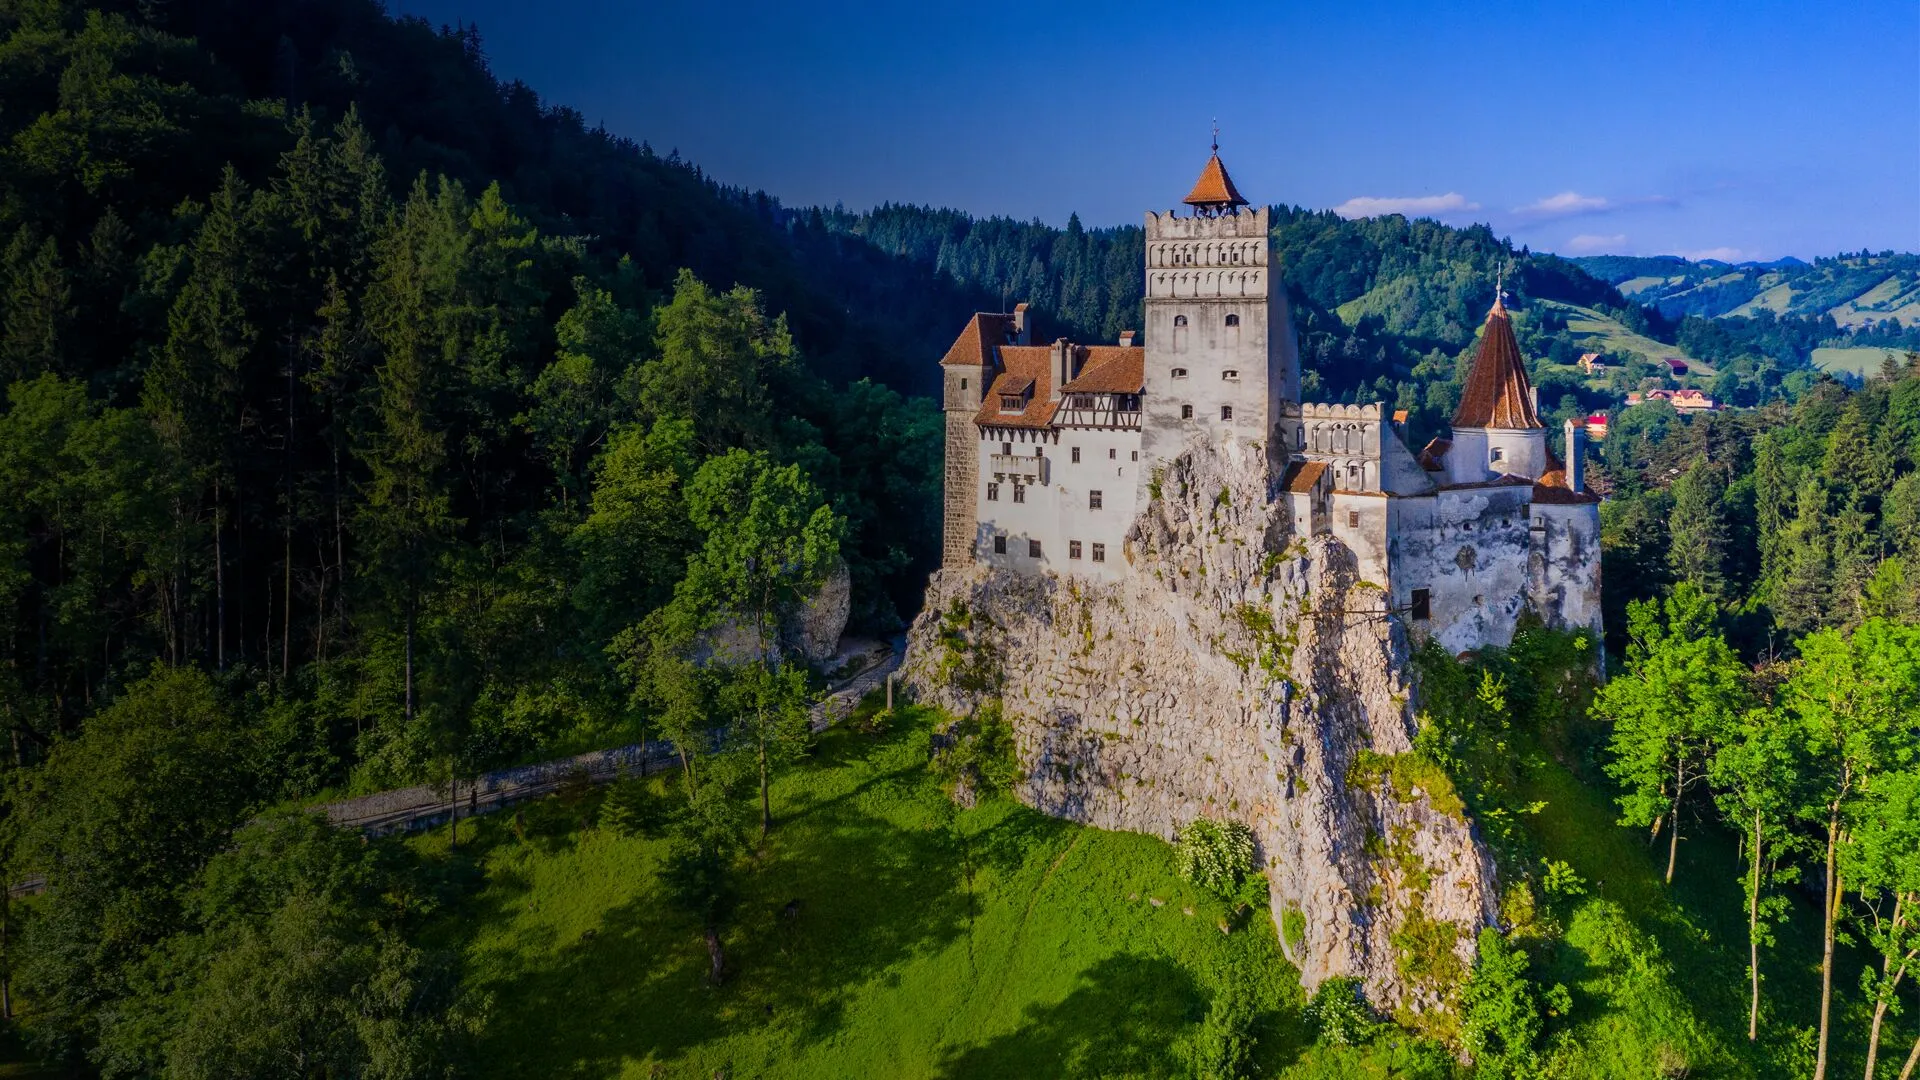If you could imagine a story happening in this castle, what would it be? Imagine a story where Bran Castle is the secret headquarters of a guild of ancient scholars. Hidden within its stone walls and towering spires lies a library filled with centuries-old manuscripts and powerful artifacts. The scholars, known as the Keepers of the Eternal Flame, have guarded a mystical flame that grants wisdom and foresight to those who possess it. However, the tranquility is shattered when a rival faction, seeking to harness the flame's power for malevolent purposes, begins their assault on the castle. The Keepers must use their knowledge, the castle's hidden passages, and its strategic defenses to protect the flame, leading to an epic battle of wit and courage under the shadow of the ancient fortress. 